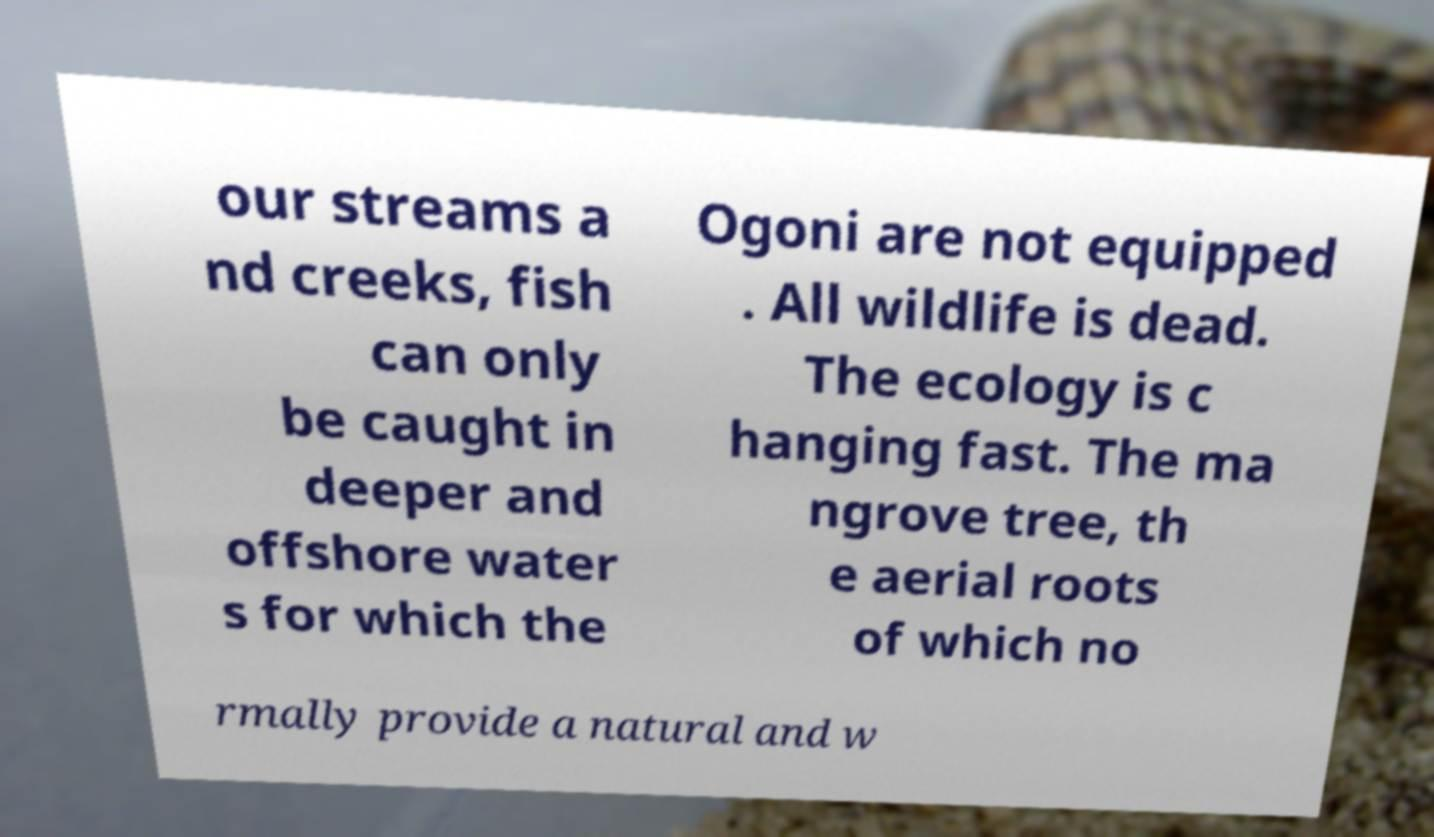For documentation purposes, I need the text within this image transcribed. Could you provide that? our streams a nd creeks, fish can only be caught in deeper and offshore water s for which the Ogoni are not equipped . All wildlife is dead. The ecology is c hanging fast. The ma ngrove tree, th e aerial roots of which no rmally provide a natural and w 